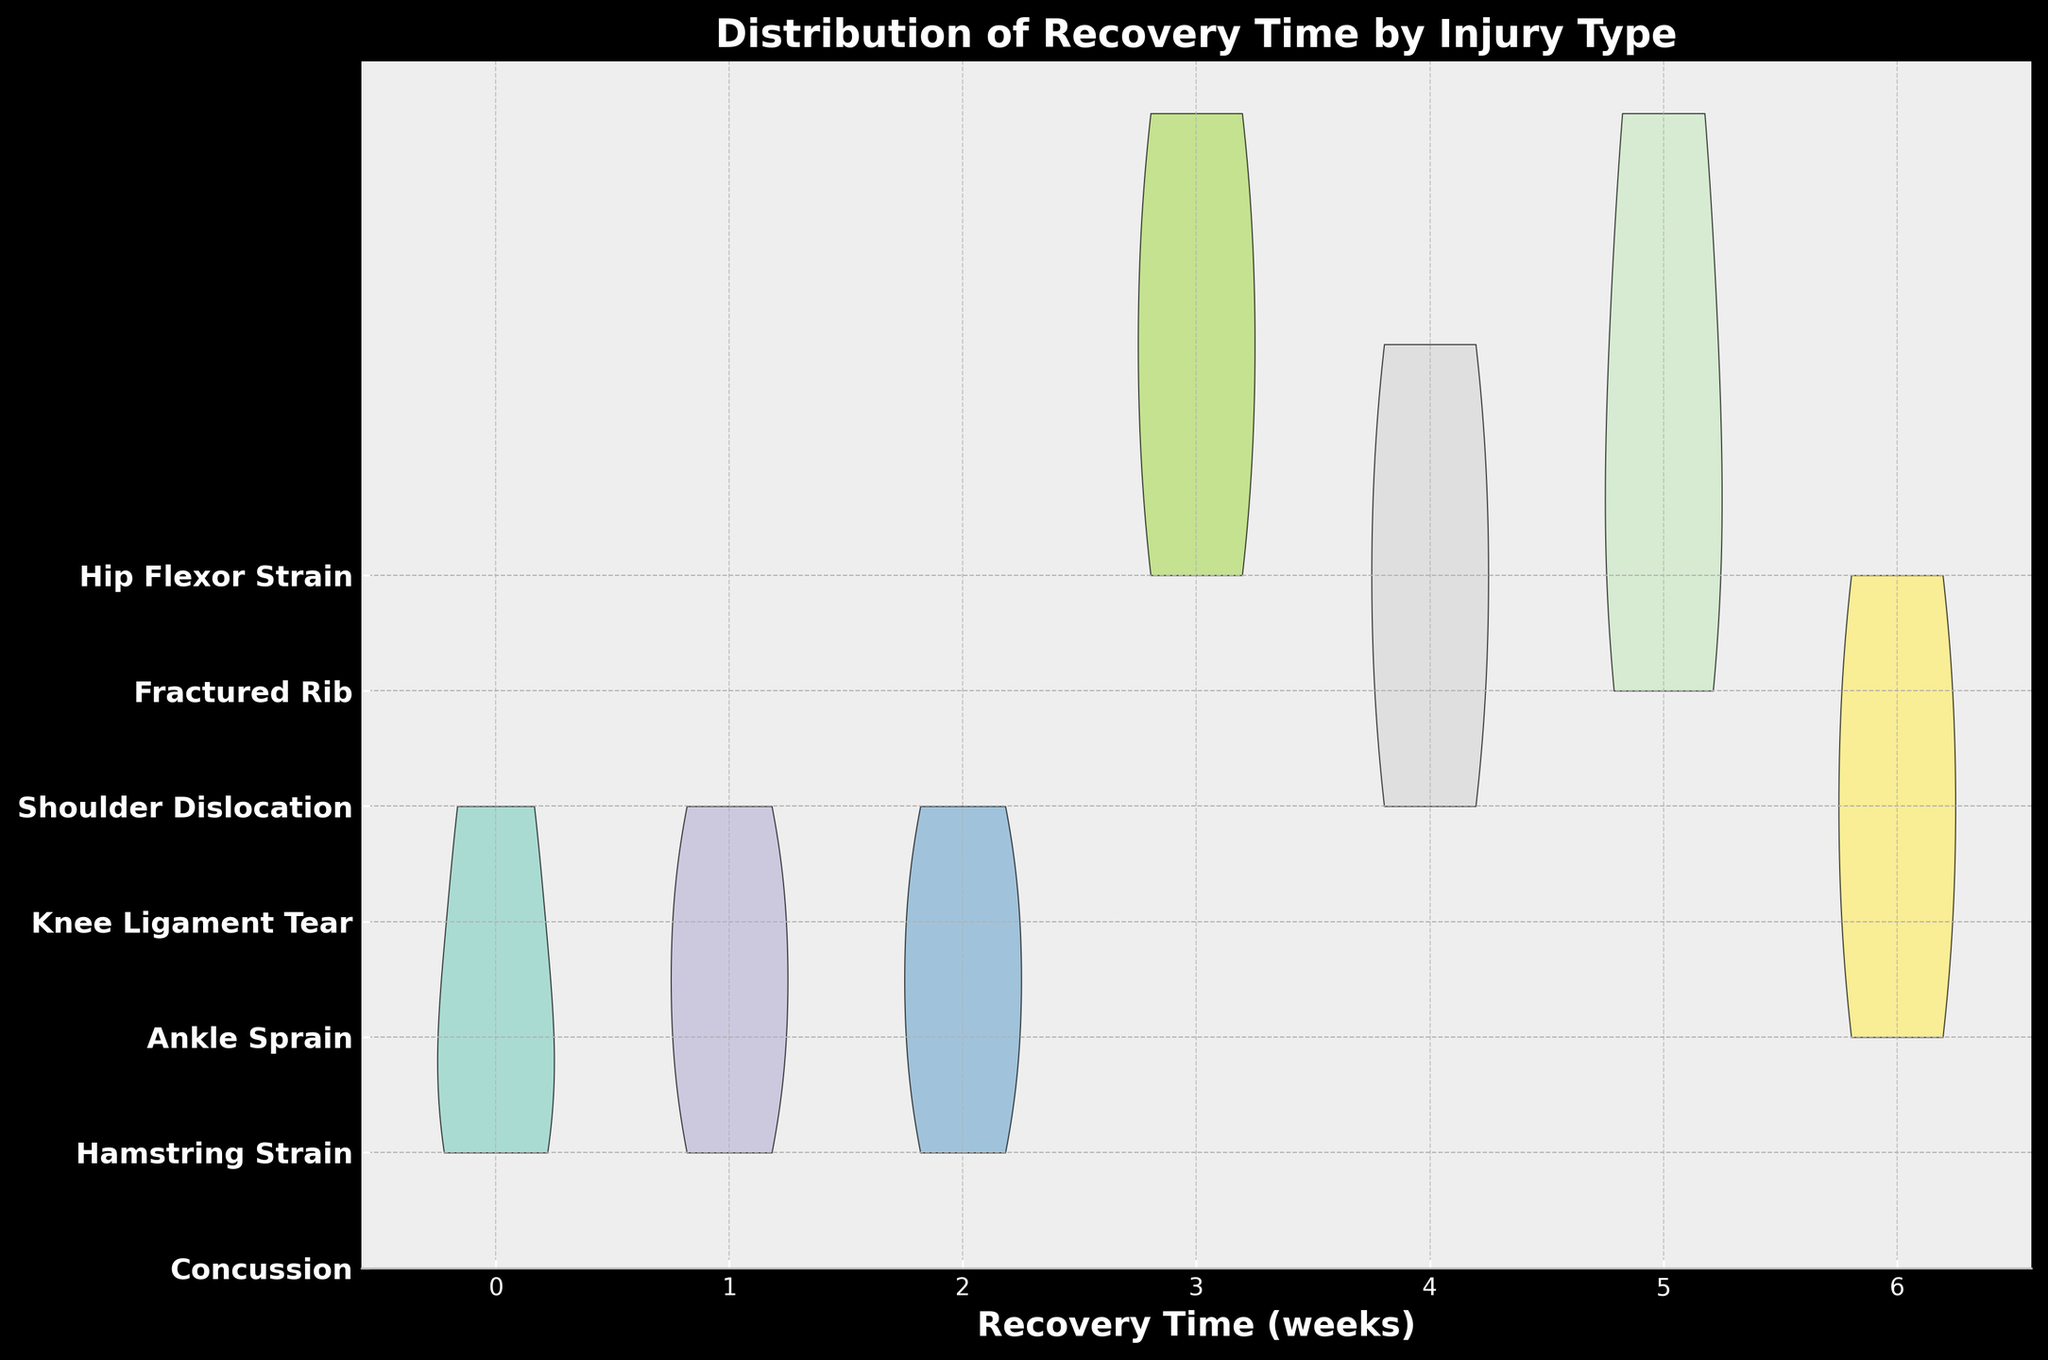What's the title of the chart? The title is usually located at the top of the chart and is displayed in a larger font size than other text elements. In this case, the title is "Distribution of Recovery Time by Injury Type".
Answer: Distribution of Recovery Time by Injury Type What is the label on the x-axis? The x-axis typically represents the variable being measured. The label here is "Recovery Time (weeks)", indicating that recovery time is measured in weeks.
Answer: Recovery Time (weeks) What injury type shows the widest distribution in recovery time? To determine the widest distribution, we need to identify the injury type whose violin plot stretches the most horizontally. The injury type with the widest horizontal span represents the widest distribution. Here, "Ankle Sprain" spans from 1 to 4 weeks, showing a broad range.
Answer: Ankle Sprain How many weeks does "Knee Ligament Tear" span in recovery time? Look at the horizontal extent of the violin plot for "Knee Ligament Tear". It stretches from 6 weeks to 10 weeks.
Answer: 4 weeks Which injury type has the most common recovery time at 1 week? To find this, we check which injury's violin plot shows a noticeable shape at the 1-week mark. "Concussion" and "Hamstring Strain" both include 1 week, but "Ankle Sprain" has a peak, indicating many cases at this recovery time.
Answer: Ankle Sprain Which injury type has the longest recovery time in the dataset? The longest recovery time can be identified by finding the maximal horizontal extent of any violin plot. "Knee Ligament Tear" has a recovery time extending up to 10 weeks.
Answer: Knee Ligament Tear What is the color used for "Fractured Rib" violations? The color for each injury type is visually distinguishable but specific color identification involves looking at the plotted violin for "Fractured Rib", which is close to green in the color palette used.
Answer: Green (color interpretation) Which injury types have recovery times of 8 weeks or more? Identify violin plots that stretch to 8 weeks or more. "Knee Ligament Tear," "Shoulder Dislocation," and "Fractured Rib" reach this range.
Answer: Knee Ligament Tear, Shoulder Dislocation, Fractured Rib How many injury types have a maximum recovery time of 4 weeks or less? Count the injury types whose violin plots do not extend beyond 4 weeks. This includes "Concussion", "Hamstring Strain", "Ankle Sprain", and "Hip Flexor Strain".
Answer: 4 injury types 